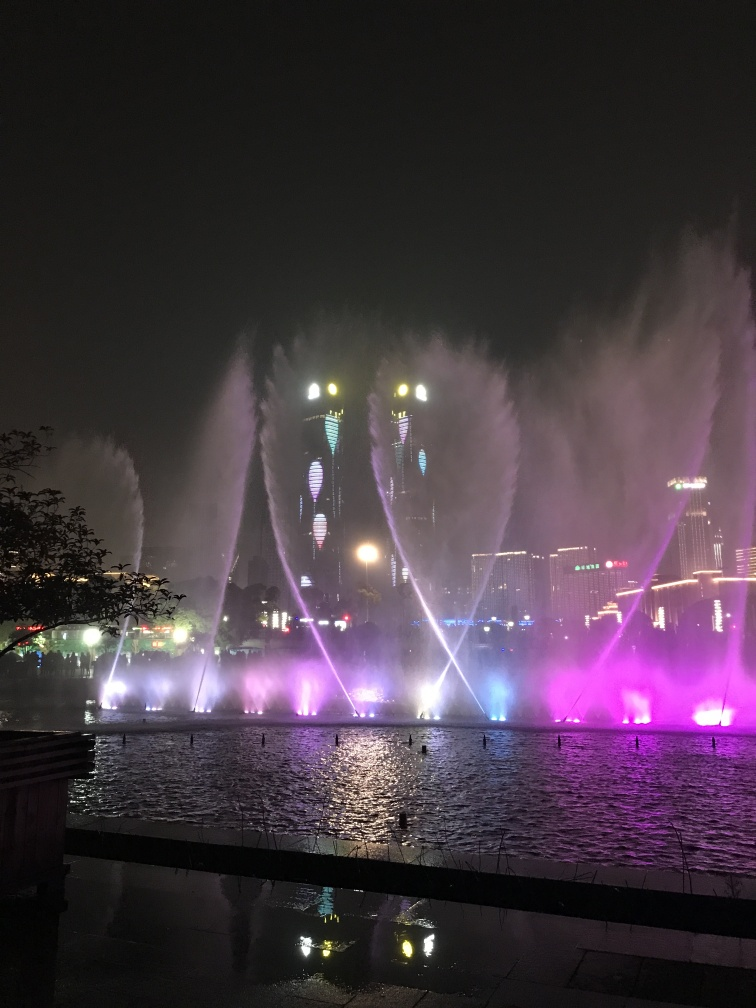What can you tell me about the location shown in the image? While I cannot provide specific geographical information, the image appears to show a modern, urban setting with a water feature that suggests it might be a part of a public entertainment area, perhaps in a city with prominent nightlife and public events. 